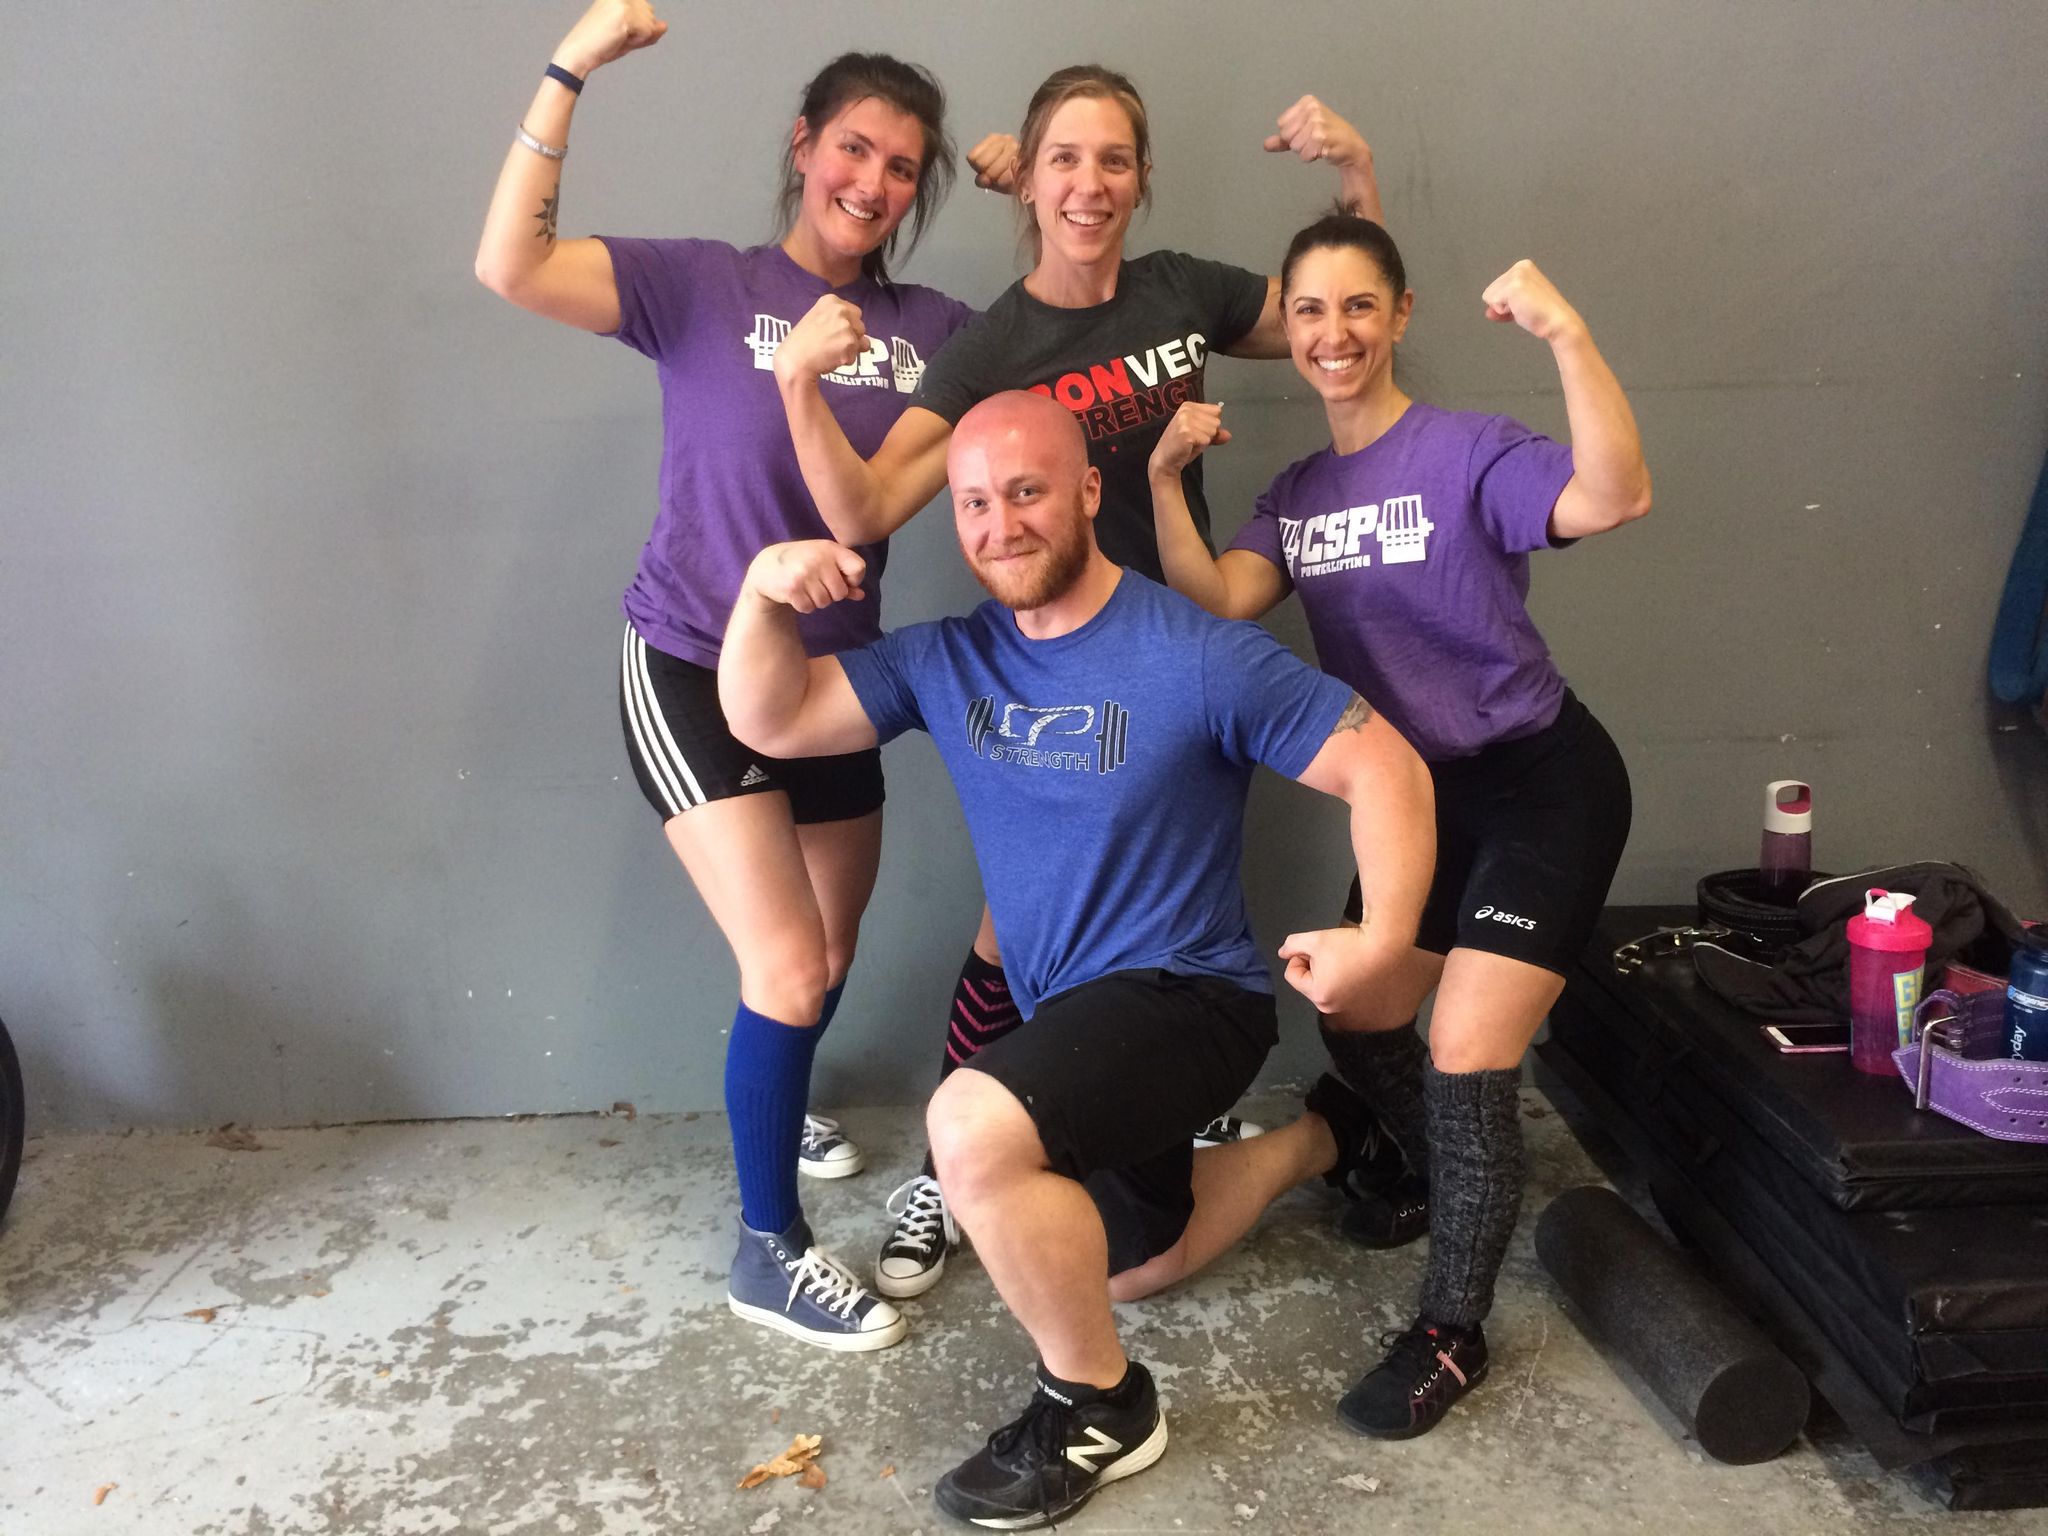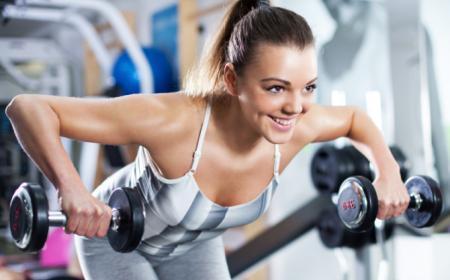The first image is the image on the left, the second image is the image on the right. For the images displayed, is the sentence "In one of the images, someone is exercising, and in the other image, people are posing." factually correct? Answer yes or no. Yes. 